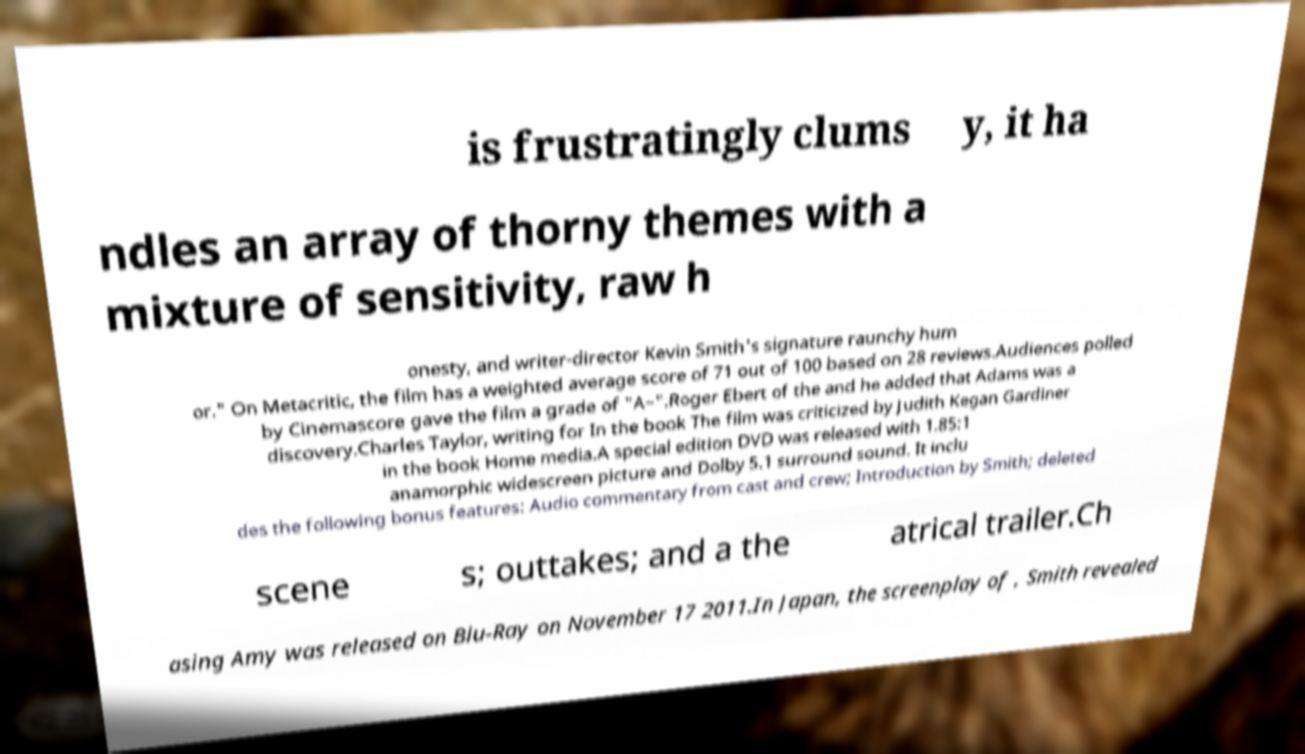There's text embedded in this image that I need extracted. Can you transcribe it verbatim? is frustratingly clums y, it ha ndles an array of thorny themes with a mixture of sensitivity, raw h onesty, and writer-director Kevin Smith's signature raunchy hum or." On Metacritic, the film has a weighted average score of 71 out of 100 based on 28 reviews.Audiences polled by Cinemascore gave the film a grade of "A–".Roger Ebert of the and he added that Adams was a discovery.Charles Taylor, writing for In the book The film was criticized by Judith Kegan Gardiner in the book Home media.A special edition DVD was released with 1.85:1 anamorphic widescreen picture and Dolby 5.1 surround sound. It inclu des the following bonus features: Audio commentary from cast and crew; Introduction by Smith; deleted scene s; outtakes; and a the atrical trailer.Ch asing Amy was released on Blu-Ray on November 17 2011.In Japan, the screenplay of , Smith revealed 